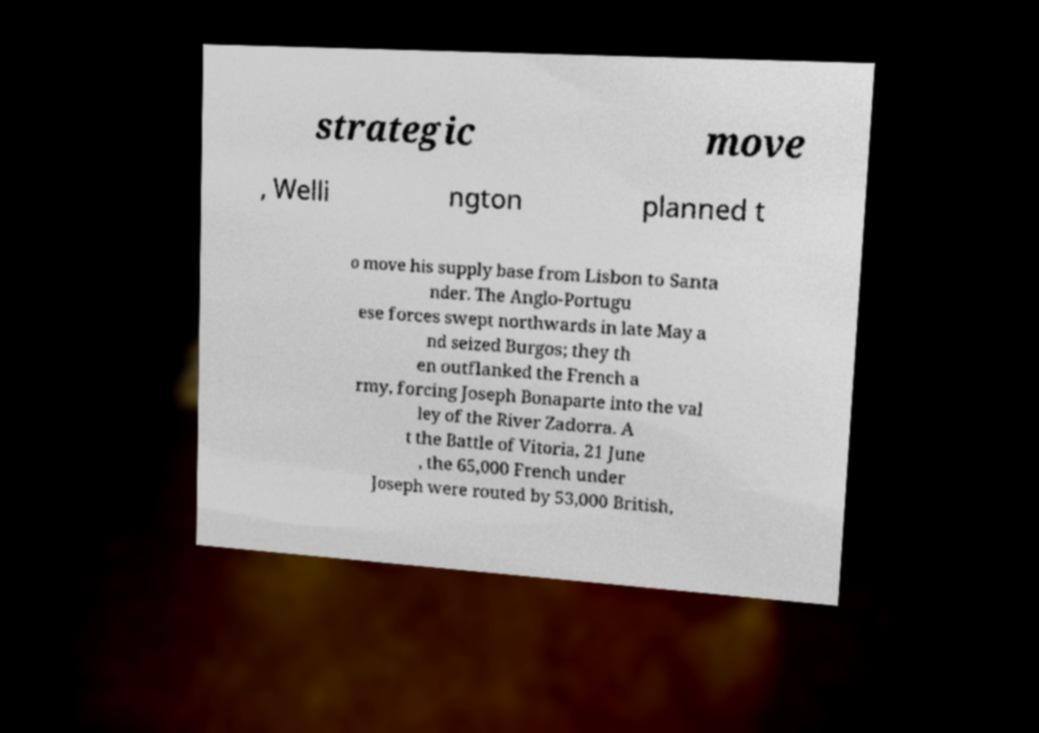Please read and relay the text visible in this image. What does it say? strategic move , Welli ngton planned t o move his supply base from Lisbon to Santa nder. The Anglo-Portugu ese forces swept northwards in late May a nd seized Burgos; they th en outflanked the French a rmy, forcing Joseph Bonaparte into the val ley of the River Zadorra. A t the Battle of Vitoria, 21 June , the 65,000 French under Joseph were routed by 53,000 British, 